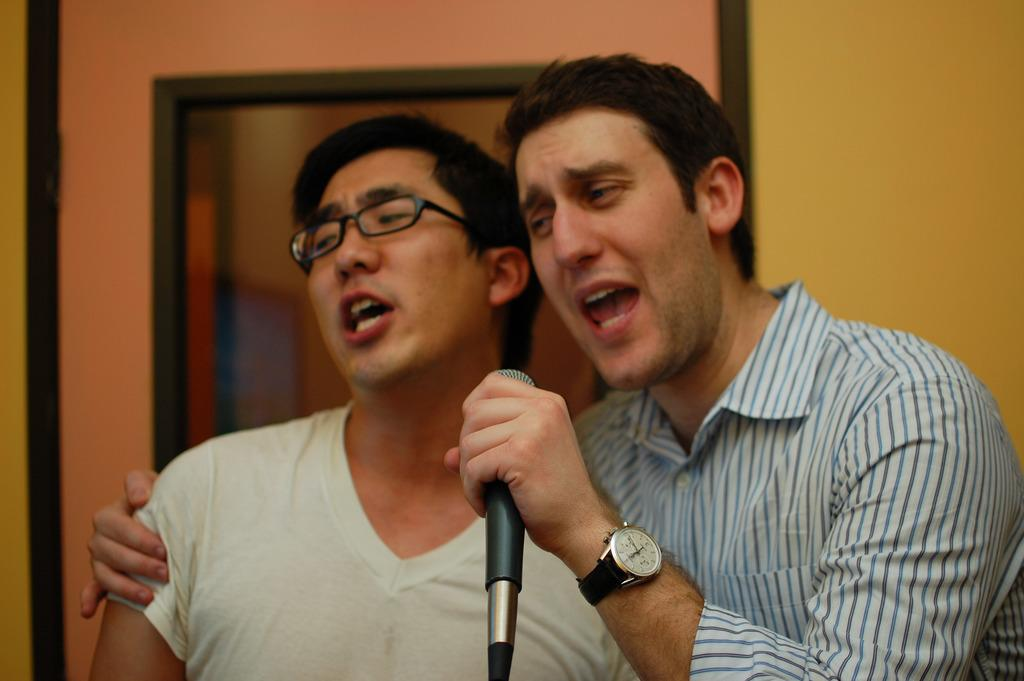How many people are in the image? There are two persons in the image. What are the persons doing in the image? Both persons are standing and singing a song. What are they holding in their hands? They are holding a mic. Can you describe the appearance of the person on the right side? The person on the right side is wearing a watch. What type of rod can be seen in the image? There is no rod present in the image. What kind of truck is visible in the background of the image? There is no truck visible in the image. 